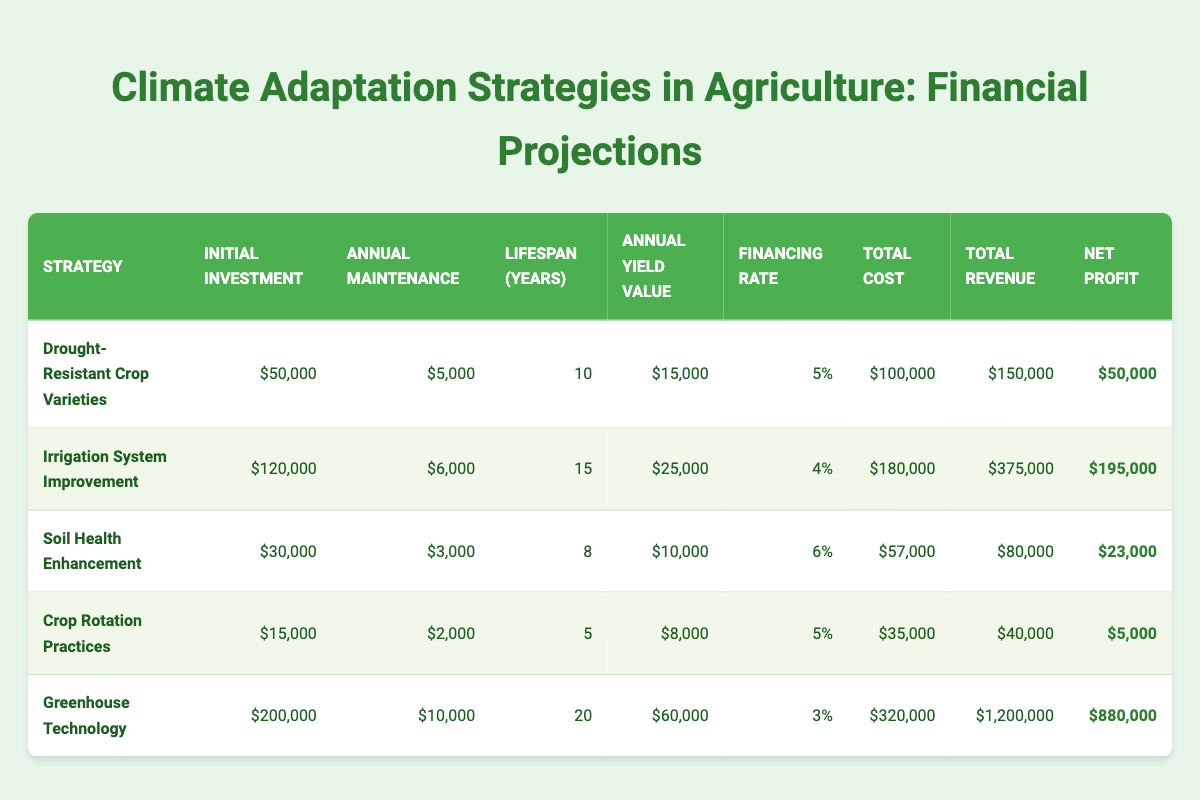What is the total revenue generated from the "Irrigation System Improvement" strategy? From the table, we see that the total revenue for the "Irrigation System Improvement" strategy is clearly stated as $375,000.
Answer: $375,000 Which strategy has the highest net profit? By examining the net profit values in the table, "Greenhouse Technology" has the highest net profit of $880,000.
Answer: $880,000 What is the average total cost of all strategies? To find the average total cost, we first sum up all total costs: $100,000 + $180,000 + $57,000 + $35,000 + $320,000 = $692,000. Then, we divide by the number of strategies, which is 5. Therefore, the average total cost is $692,000 / 5 = $138,400.
Answer: $138,400 Does the "Soil Health Enhancement" strategy have a higher annual maintenance cost than the "Crop Rotation Practices" strategy? The annual maintenance cost for "Soil Health Enhancement" is $3,000 and for "Crop Rotation Practices," it is $2,000. Since $3,000 is greater than $2,000, the answer is yes.
Answer: Yes What is the total financial gain from the "Drought-Resistant Crop Varieties" strategy compared to its total cost? The financial gain is calculated by subtracting the total cost from the total revenue for "Drought-Resistant Crop Varieties." The total revenue is $150,000 and the total cost is $100,000, which gives a financial gain of $150,000 - $100,000 = $50,000.
Answer: $50,000 How much lower is the initial investment for "Crop Rotation Practices" compared to "Greenhouse Technology"? The initial investment for "Crop Rotation Practices" is $15,000, while for "Greenhouse Technology" it is $200,000. The difference is $200,000 - $15,000 = $185,000, meaning "Crop Rotation Practices" is $185,000 lower.
Answer: $185,000 What percentage of the annual yield value does the "Soil Health Enhancement" strategy contribute compared to its total revenue? The annual yield value for "Soil Health Enhancement" is $10,000 and the total revenue is $80,000. To find the percentage, we calculate ($10,000 / $80,000) * 100 = 12.5%.
Answer: 12.5% Are the total costs for "Drought-Resistant Crop Varieties" and "Crop Rotation Practices" together greater than that of "Soil Health Enhancement"? The total costs are $100,000 for "Drought-Resistant Crop Varieties" and $35,000 for "Crop Rotation Practices," totaling $135,000. "Soil Health Enhancement" has a total cost of $57,000. Since $135,000 is greater than $57,000, the answer is yes.
Answer: Yes 